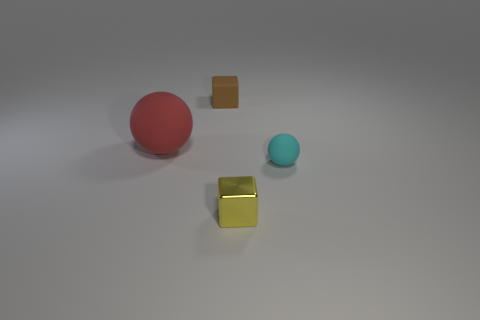What number of matte things are yellow spheres or red spheres?
Your answer should be compact. 1. The cyan thing that is the same material as the small brown cube is what shape?
Provide a short and direct response. Sphere. How many matte balls are to the left of the brown rubber block and to the right of the brown matte object?
Provide a succinct answer. 0. Is there any other thing that is the same shape as the red object?
Keep it short and to the point. Yes. How big is the object in front of the tiny sphere?
Keep it short and to the point. Small. How many other things are there of the same color as the small metallic cube?
Offer a very short reply. 0. The small cube that is behind the matte sphere to the right of the tiny brown thing is made of what material?
Keep it short and to the point. Rubber. Is there any other thing that is the same material as the tiny yellow thing?
Offer a terse response. No. How many small things are the same shape as the big object?
Keep it short and to the point. 1. There is a cyan object that is made of the same material as the small brown object; what size is it?
Your answer should be very brief. Small. 